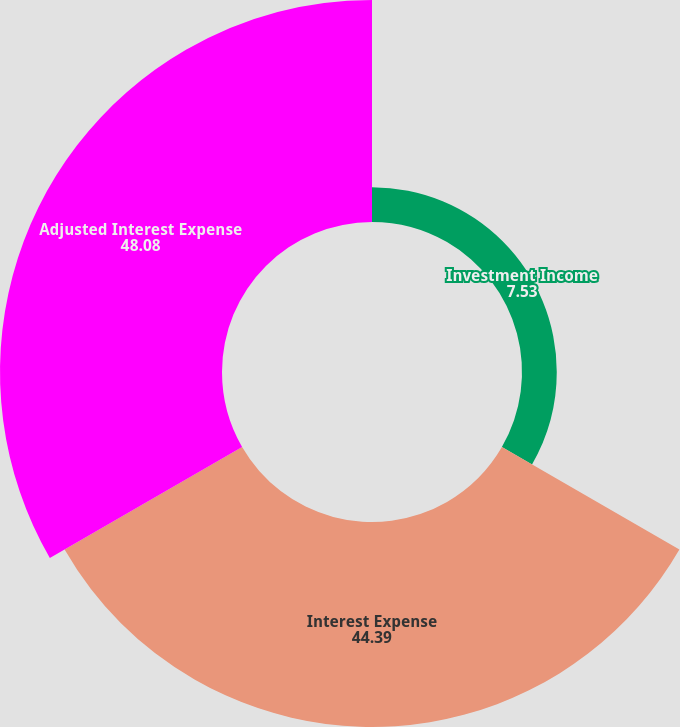Convert chart. <chart><loc_0><loc_0><loc_500><loc_500><pie_chart><fcel>Investment Income<fcel>Interest Expense<fcel>Adjusted Interest Expense<nl><fcel>7.53%<fcel>44.39%<fcel>48.08%<nl></chart> 